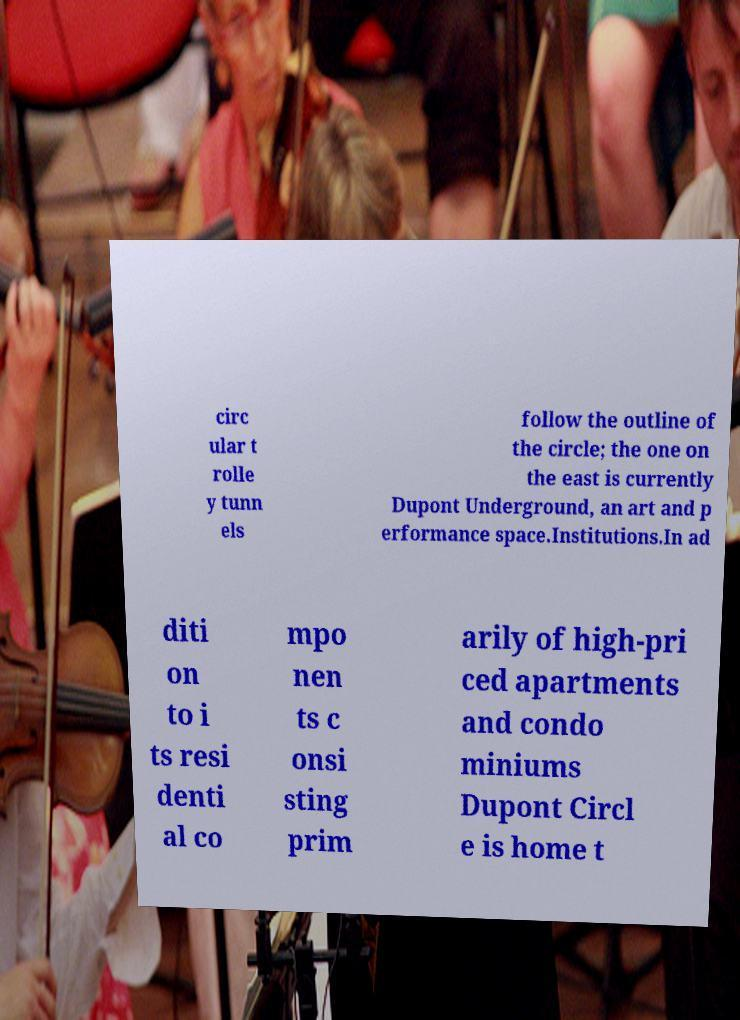Can you read and provide the text displayed in the image?This photo seems to have some interesting text. Can you extract and type it out for me? circ ular t rolle y tunn els follow the outline of the circle; the one on the east is currently Dupont Underground, an art and p erformance space.Institutions.In ad diti on to i ts resi denti al co mpo nen ts c onsi sting prim arily of high-pri ced apartments and condo miniums Dupont Circl e is home t 